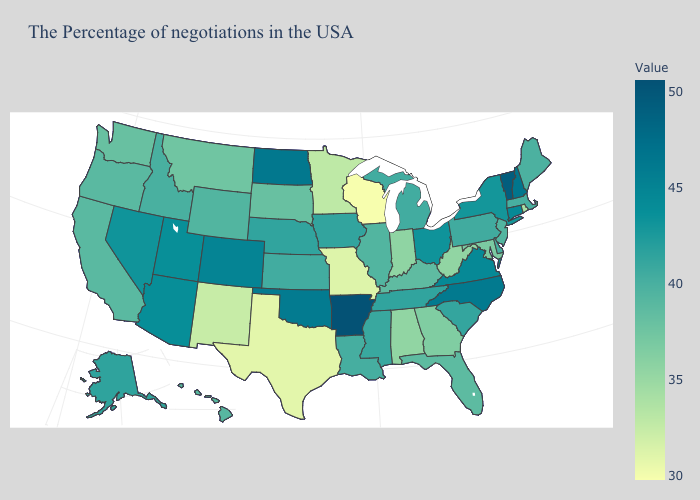Does the map have missing data?
Quick response, please. No. Which states hav the highest value in the South?
Keep it brief. Arkansas. Is the legend a continuous bar?
Short answer required. Yes. Which states have the highest value in the USA?
Concise answer only. Arkansas. Which states have the highest value in the USA?
Be succinct. Arkansas. 